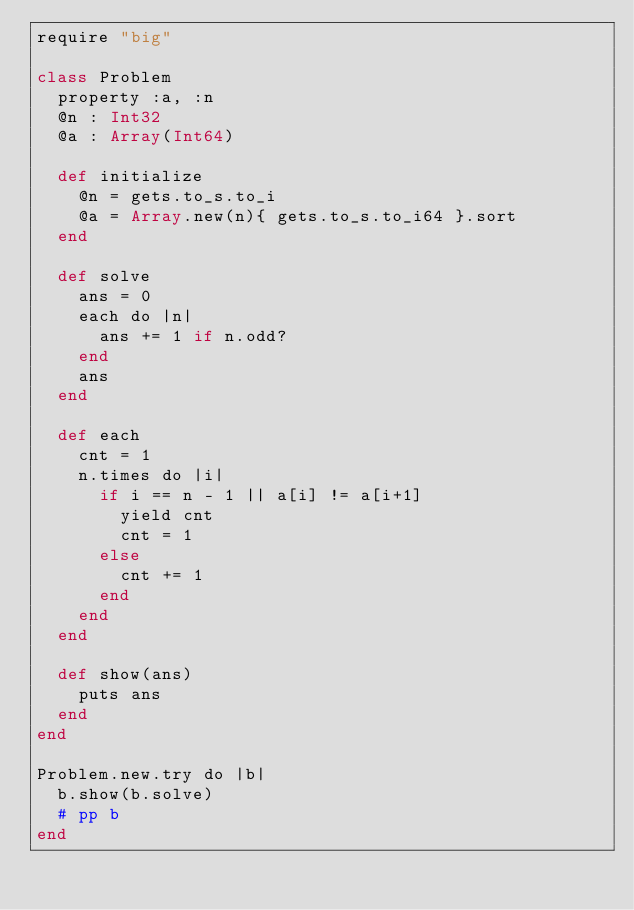Convert code to text. <code><loc_0><loc_0><loc_500><loc_500><_Crystal_>require "big"

class Problem
  property :a, :n
  @n : Int32
  @a : Array(Int64)

  def initialize
    @n = gets.to_s.to_i
    @a = Array.new(n){ gets.to_s.to_i64 }.sort
  end
  
  def solve
    ans = 0
    each do |n|
      ans += 1 if n.odd?
    end
    ans
  end

  def each
    cnt = 1
    n.times do |i|
      if i == n - 1 || a[i] != a[i+1]
        yield cnt
        cnt = 1
      else
        cnt += 1
      end
    end
  end

  def show(ans)
    puts ans
  end
end

Problem.new.try do |b|
  b.show(b.solve)
  # pp b
end

</code> 